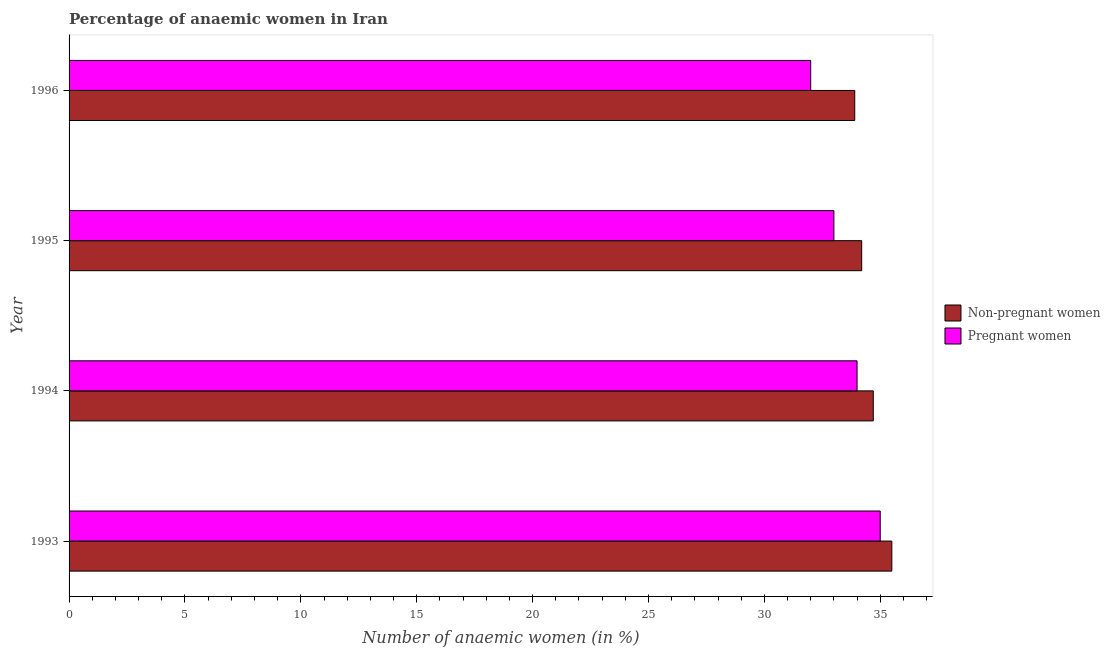How many different coloured bars are there?
Ensure brevity in your answer.  2. Are the number of bars on each tick of the Y-axis equal?
Your answer should be very brief. Yes. How many bars are there on the 3rd tick from the top?
Provide a succinct answer. 2. How many bars are there on the 4th tick from the bottom?
Give a very brief answer. 2. In how many cases, is the number of bars for a given year not equal to the number of legend labels?
Provide a succinct answer. 0. What is the percentage of pregnant anaemic women in 1994?
Offer a very short reply. 34. Across all years, what is the minimum percentage of non-pregnant anaemic women?
Give a very brief answer. 33.9. In which year was the percentage of pregnant anaemic women maximum?
Offer a very short reply. 1993. In which year was the percentage of non-pregnant anaemic women minimum?
Give a very brief answer. 1996. What is the total percentage of pregnant anaemic women in the graph?
Keep it short and to the point. 134. What is the difference between the percentage of pregnant anaemic women in 1995 and that in 1996?
Offer a very short reply. 1. What is the difference between the percentage of pregnant anaemic women in 1995 and the percentage of non-pregnant anaemic women in 1996?
Offer a very short reply. -0.9. What is the average percentage of pregnant anaemic women per year?
Your answer should be compact. 33.5. What is the ratio of the percentage of pregnant anaemic women in 1994 to that in 1996?
Provide a succinct answer. 1.06. Is the percentage of pregnant anaemic women in 1993 less than that in 1994?
Make the answer very short. No. Is the difference between the percentage of non-pregnant anaemic women in 1994 and 1996 greater than the difference between the percentage of pregnant anaemic women in 1994 and 1996?
Provide a succinct answer. No. What is the difference between the highest and the lowest percentage of non-pregnant anaemic women?
Provide a short and direct response. 1.6. What does the 2nd bar from the top in 1995 represents?
Provide a short and direct response. Non-pregnant women. What does the 2nd bar from the bottom in 1993 represents?
Ensure brevity in your answer.  Pregnant women. How many years are there in the graph?
Your answer should be compact. 4. What is the difference between two consecutive major ticks on the X-axis?
Provide a short and direct response. 5. Are the values on the major ticks of X-axis written in scientific E-notation?
Provide a succinct answer. No. Does the graph contain any zero values?
Provide a succinct answer. No. Where does the legend appear in the graph?
Give a very brief answer. Center right. How many legend labels are there?
Keep it short and to the point. 2. What is the title of the graph?
Provide a short and direct response. Percentage of anaemic women in Iran. Does "Short-term debt" appear as one of the legend labels in the graph?
Provide a short and direct response. No. What is the label or title of the X-axis?
Give a very brief answer. Number of anaemic women (in %). What is the label or title of the Y-axis?
Make the answer very short. Year. What is the Number of anaemic women (in %) of Non-pregnant women in 1993?
Offer a very short reply. 35.5. What is the Number of anaemic women (in %) in Non-pregnant women in 1994?
Offer a terse response. 34.7. What is the Number of anaemic women (in %) in Non-pregnant women in 1995?
Your answer should be very brief. 34.2. What is the Number of anaemic women (in %) in Non-pregnant women in 1996?
Your answer should be compact. 33.9. What is the Number of anaemic women (in %) of Pregnant women in 1996?
Keep it short and to the point. 32. Across all years, what is the maximum Number of anaemic women (in %) of Non-pregnant women?
Your response must be concise. 35.5. Across all years, what is the maximum Number of anaemic women (in %) in Pregnant women?
Your response must be concise. 35. Across all years, what is the minimum Number of anaemic women (in %) of Non-pregnant women?
Provide a succinct answer. 33.9. Across all years, what is the minimum Number of anaemic women (in %) in Pregnant women?
Ensure brevity in your answer.  32. What is the total Number of anaemic women (in %) in Non-pregnant women in the graph?
Your answer should be compact. 138.3. What is the total Number of anaemic women (in %) of Pregnant women in the graph?
Give a very brief answer. 134. What is the difference between the Number of anaemic women (in %) of Non-pregnant women in 1993 and that in 1994?
Provide a short and direct response. 0.8. What is the difference between the Number of anaemic women (in %) of Non-pregnant women in 1993 and that in 1995?
Your answer should be compact. 1.3. What is the difference between the Number of anaemic women (in %) in Pregnant women in 1993 and that in 1995?
Offer a very short reply. 2. What is the difference between the Number of anaemic women (in %) in Non-pregnant women in 1993 and that in 1996?
Offer a terse response. 1.6. What is the difference between the Number of anaemic women (in %) of Pregnant women in 1993 and that in 1996?
Offer a terse response. 3. What is the difference between the Number of anaemic women (in %) in Pregnant women in 1994 and that in 1995?
Provide a succinct answer. 1. What is the difference between the Number of anaemic women (in %) of Non-pregnant women in 1994 and that in 1996?
Provide a succinct answer. 0.8. What is the difference between the Number of anaemic women (in %) in Non-pregnant women in 1995 and that in 1996?
Offer a terse response. 0.3. What is the difference between the Number of anaemic women (in %) in Pregnant women in 1995 and that in 1996?
Keep it short and to the point. 1. What is the difference between the Number of anaemic women (in %) of Non-pregnant women in 1994 and the Number of anaemic women (in %) of Pregnant women in 1996?
Give a very brief answer. 2.7. What is the average Number of anaemic women (in %) of Non-pregnant women per year?
Your answer should be very brief. 34.58. What is the average Number of anaemic women (in %) of Pregnant women per year?
Your answer should be very brief. 33.5. In the year 1993, what is the difference between the Number of anaemic women (in %) in Non-pregnant women and Number of anaemic women (in %) in Pregnant women?
Your answer should be compact. 0.5. What is the ratio of the Number of anaemic women (in %) of Non-pregnant women in 1993 to that in 1994?
Make the answer very short. 1.02. What is the ratio of the Number of anaemic women (in %) of Pregnant women in 1993 to that in 1994?
Offer a very short reply. 1.03. What is the ratio of the Number of anaemic women (in %) of Non-pregnant women in 1993 to that in 1995?
Your answer should be very brief. 1.04. What is the ratio of the Number of anaemic women (in %) of Pregnant women in 1993 to that in 1995?
Offer a terse response. 1.06. What is the ratio of the Number of anaemic women (in %) in Non-pregnant women in 1993 to that in 1996?
Provide a short and direct response. 1.05. What is the ratio of the Number of anaemic women (in %) of Pregnant women in 1993 to that in 1996?
Keep it short and to the point. 1.09. What is the ratio of the Number of anaemic women (in %) of Non-pregnant women in 1994 to that in 1995?
Your answer should be very brief. 1.01. What is the ratio of the Number of anaemic women (in %) of Pregnant women in 1994 to that in 1995?
Ensure brevity in your answer.  1.03. What is the ratio of the Number of anaemic women (in %) of Non-pregnant women in 1994 to that in 1996?
Provide a succinct answer. 1.02. What is the ratio of the Number of anaemic women (in %) of Pregnant women in 1994 to that in 1996?
Make the answer very short. 1.06. What is the ratio of the Number of anaemic women (in %) in Non-pregnant women in 1995 to that in 1996?
Give a very brief answer. 1.01. What is the ratio of the Number of anaemic women (in %) of Pregnant women in 1995 to that in 1996?
Provide a short and direct response. 1.03. What is the difference between the highest and the second highest Number of anaemic women (in %) of Non-pregnant women?
Keep it short and to the point. 0.8. What is the difference between the highest and the second highest Number of anaemic women (in %) in Pregnant women?
Keep it short and to the point. 1. 